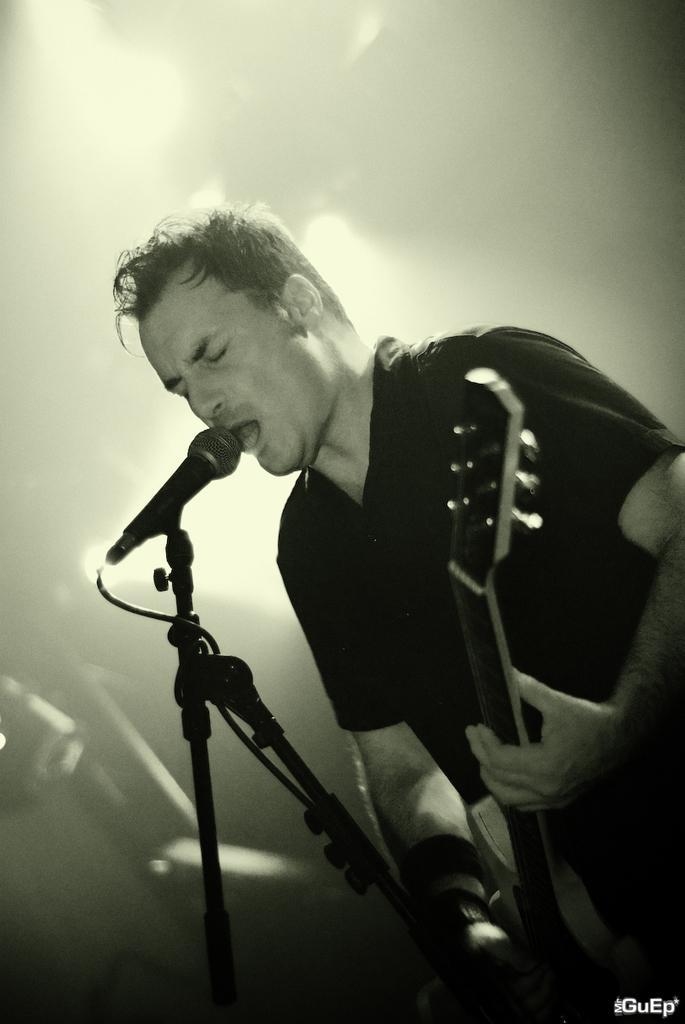Describe this image in one or two sentences. In this image I can see a man is holding a guitar, I can also see a mic in front of him. Here I can see he is wearing a t-shirt. 